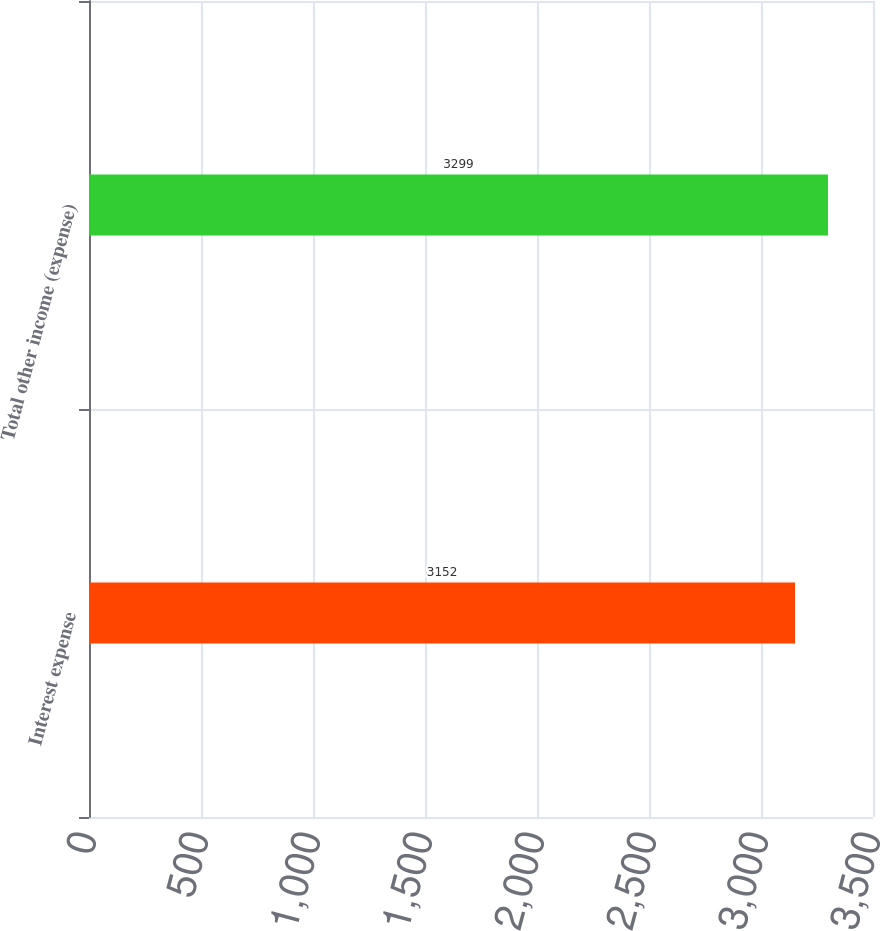Convert chart to OTSL. <chart><loc_0><loc_0><loc_500><loc_500><bar_chart><fcel>Interest expense<fcel>Total other income (expense)<nl><fcel>3152<fcel>3299<nl></chart> 